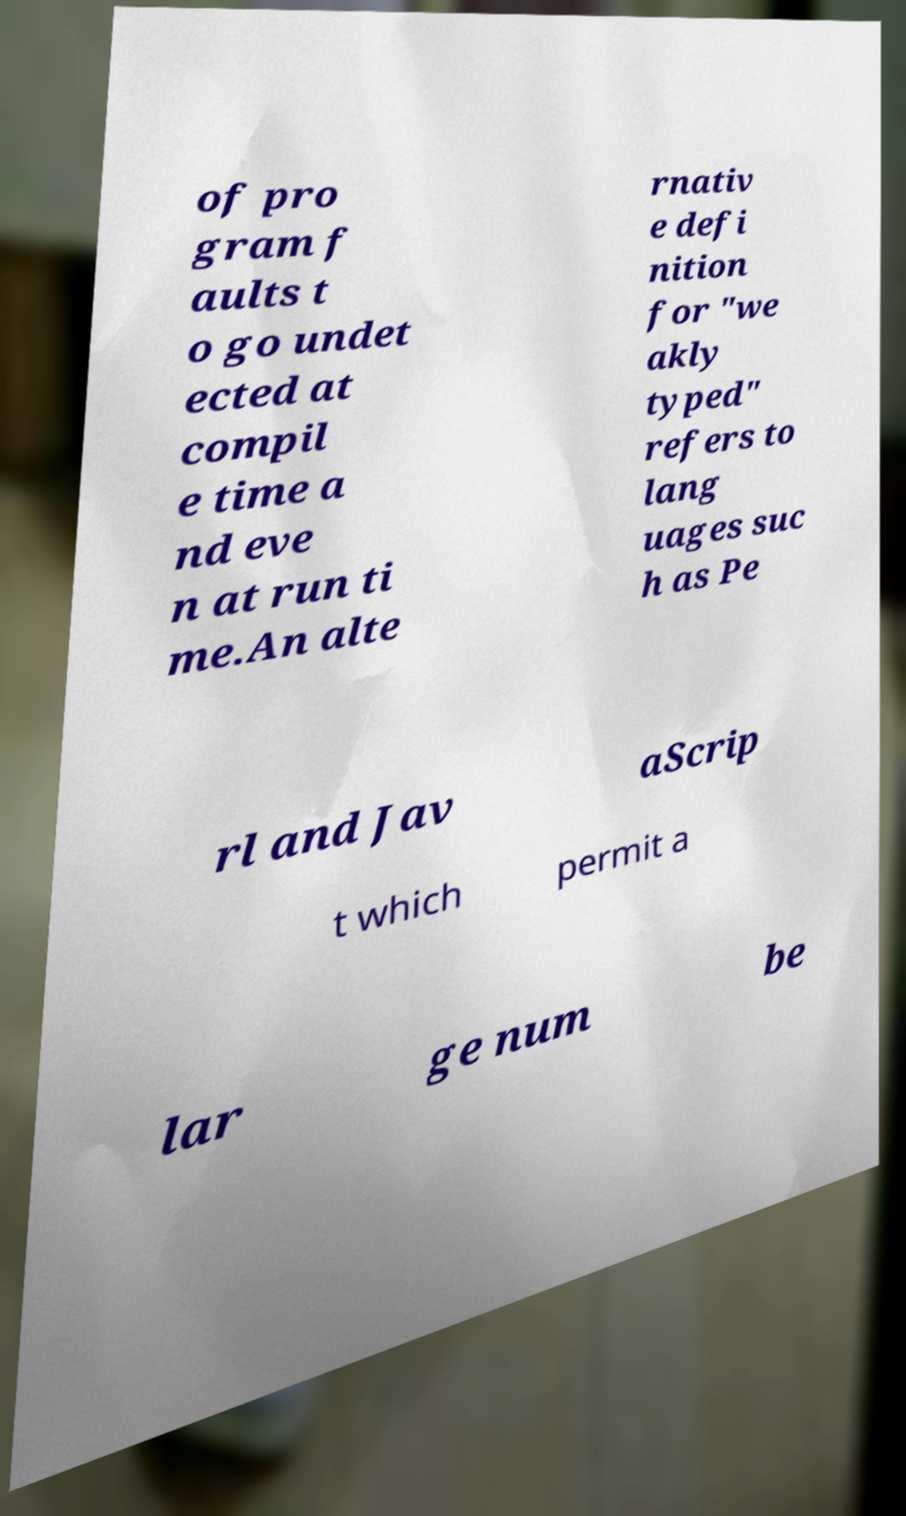Can you accurately transcribe the text from the provided image for me? of pro gram f aults t o go undet ected at compil e time a nd eve n at run ti me.An alte rnativ e defi nition for "we akly typed" refers to lang uages suc h as Pe rl and Jav aScrip t which permit a lar ge num be 